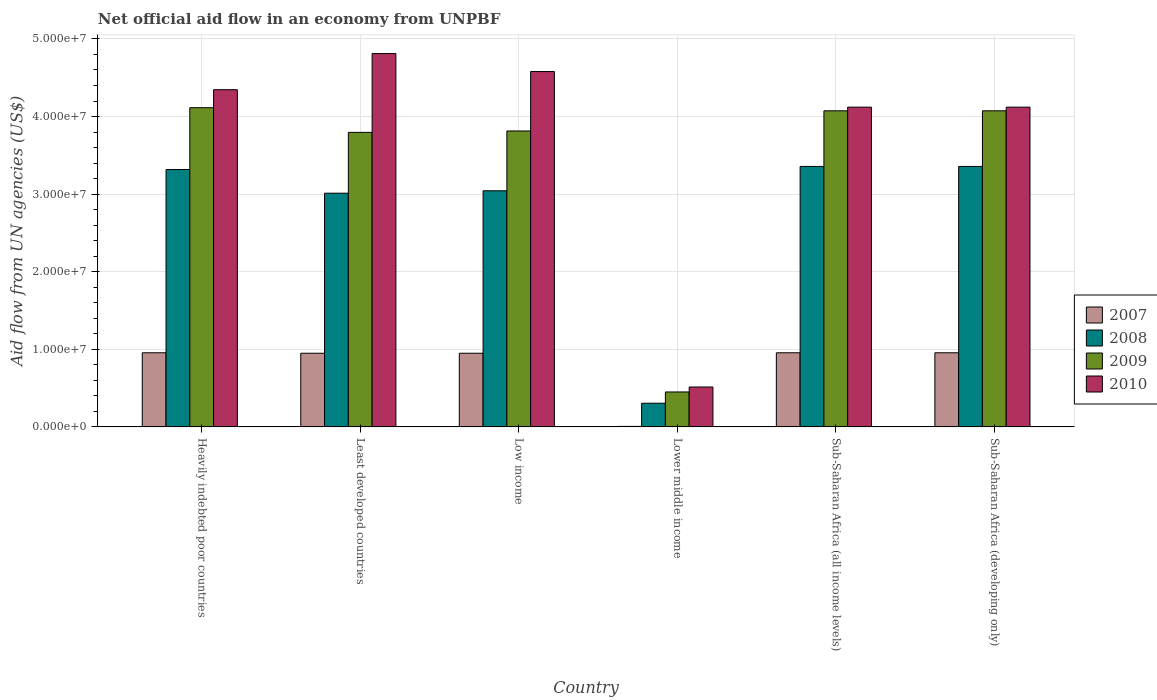How many different coloured bars are there?
Provide a short and direct response. 4. How many groups of bars are there?
Provide a short and direct response. 6. How many bars are there on the 3rd tick from the left?
Make the answer very short. 4. How many bars are there on the 2nd tick from the right?
Offer a terse response. 4. What is the label of the 5th group of bars from the left?
Offer a terse response. Sub-Saharan Africa (all income levels). In how many cases, is the number of bars for a given country not equal to the number of legend labels?
Your response must be concise. 0. What is the net official aid flow in 2007 in Sub-Saharan Africa (all income levels)?
Offer a terse response. 9.55e+06. Across all countries, what is the maximum net official aid flow in 2008?
Offer a terse response. 3.36e+07. Across all countries, what is the minimum net official aid flow in 2008?
Give a very brief answer. 3.05e+06. In which country was the net official aid flow in 2009 maximum?
Provide a short and direct response. Heavily indebted poor countries. In which country was the net official aid flow in 2009 minimum?
Provide a short and direct response. Lower middle income. What is the total net official aid flow in 2010 in the graph?
Ensure brevity in your answer.  2.25e+08. What is the difference between the net official aid flow in 2008 in Heavily indebted poor countries and that in Sub-Saharan Africa (developing only)?
Provide a succinct answer. -4.00e+05. What is the difference between the net official aid flow in 2010 in Sub-Saharan Africa (developing only) and the net official aid flow in 2007 in Sub-Saharan Africa (all income levels)?
Offer a very short reply. 3.17e+07. What is the average net official aid flow in 2010 per country?
Ensure brevity in your answer.  3.75e+07. What is the difference between the net official aid flow of/in 2009 and net official aid flow of/in 2010 in Low income?
Offer a very short reply. -7.66e+06. What is the ratio of the net official aid flow in 2007 in Sub-Saharan Africa (all income levels) to that in Sub-Saharan Africa (developing only)?
Keep it short and to the point. 1. Is the net official aid flow in 2008 in Least developed countries less than that in Low income?
Give a very brief answer. Yes. What is the difference between the highest and the second highest net official aid flow in 2009?
Offer a terse response. 4.00e+05. What is the difference between the highest and the lowest net official aid flow in 2010?
Give a very brief answer. 4.30e+07. Is the sum of the net official aid flow in 2009 in Heavily indebted poor countries and Lower middle income greater than the maximum net official aid flow in 2007 across all countries?
Your answer should be very brief. Yes. Is it the case that in every country, the sum of the net official aid flow in 2009 and net official aid flow in 2007 is greater than the sum of net official aid flow in 2010 and net official aid flow in 2008?
Your response must be concise. No. What does the 4th bar from the left in Sub-Saharan Africa (developing only) represents?
Keep it short and to the point. 2010. How many countries are there in the graph?
Provide a succinct answer. 6. Does the graph contain grids?
Keep it short and to the point. Yes. Where does the legend appear in the graph?
Provide a short and direct response. Center right. How many legend labels are there?
Keep it short and to the point. 4. How are the legend labels stacked?
Give a very brief answer. Vertical. What is the title of the graph?
Keep it short and to the point. Net official aid flow in an economy from UNPBF. What is the label or title of the X-axis?
Your answer should be very brief. Country. What is the label or title of the Y-axis?
Your answer should be compact. Aid flow from UN agencies (US$). What is the Aid flow from UN agencies (US$) of 2007 in Heavily indebted poor countries?
Make the answer very short. 9.55e+06. What is the Aid flow from UN agencies (US$) of 2008 in Heavily indebted poor countries?
Provide a short and direct response. 3.32e+07. What is the Aid flow from UN agencies (US$) of 2009 in Heavily indebted poor countries?
Your response must be concise. 4.11e+07. What is the Aid flow from UN agencies (US$) in 2010 in Heavily indebted poor countries?
Offer a terse response. 4.35e+07. What is the Aid flow from UN agencies (US$) in 2007 in Least developed countries?
Give a very brief answer. 9.49e+06. What is the Aid flow from UN agencies (US$) of 2008 in Least developed countries?
Make the answer very short. 3.01e+07. What is the Aid flow from UN agencies (US$) of 2009 in Least developed countries?
Provide a short and direct response. 3.80e+07. What is the Aid flow from UN agencies (US$) of 2010 in Least developed countries?
Your answer should be very brief. 4.81e+07. What is the Aid flow from UN agencies (US$) of 2007 in Low income?
Offer a very short reply. 9.49e+06. What is the Aid flow from UN agencies (US$) in 2008 in Low income?
Ensure brevity in your answer.  3.04e+07. What is the Aid flow from UN agencies (US$) of 2009 in Low income?
Offer a terse response. 3.81e+07. What is the Aid flow from UN agencies (US$) in 2010 in Low income?
Provide a short and direct response. 4.58e+07. What is the Aid flow from UN agencies (US$) in 2008 in Lower middle income?
Offer a very short reply. 3.05e+06. What is the Aid flow from UN agencies (US$) in 2009 in Lower middle income?
Make the answer very short. 4.50e+06. What is the Aid flow from UN agencies (US$) of 2010 in Lower middle income?
Your response must be concise. 5.14e+06. What is the Aid flow from UN agencies (US$) of 2007 in Sub-Saharan Africa (all income levels)?
Ensure brevity in your answer.  9.55e+06. What is the Aid flow from UN agencies (US$) of 2008 in Sub-Saharan Africa (all income levels)?
Your answer should be compact. 3.36e+07. What is the Aid flow from UN agencies (US$) of 2009 in Sub-Saharan Africa (all income levels)?
Offer a terse response. 4.07e+07. What is the Aid flow from UN agencies (US$) in 2010 in Sub-Saharan Africa (all income levels)?
Your response must be concise. 4.12e+07. What is the Aid flow from UN agencies (US$) in 2007 in Sub-Saharan Africa (developing only)?
Your answer should be compact. 9.55e+06. What is the Aid flow from UN agencies (US$) in 2008 in Sub-Saharan Africa (developing only)?
Provide a short and direct response. 3.36e+07. What is the Aid flow from UN agencies (US$) in 2009 in Sub-Saharan Africa (developing only)?
Your answer should be very brief. 4.07e+07. What is the Aid flow from UN agencies (US$) in 2010 in Sub-Saharan Africa (developing only)?
Provide a succinct answer. 4.12e+07. Across all countries, what is the maximum Aid flow from UN agencies (US$) of 2007?
Make the answer very short. 9.55e+06. Across all countries, what is the maximum Aid flow from UN agencies (US$) of 2008?
Your response must be concise. 3.36e+07. Across all countries, what is the maximum Aid flow from UN agencies (US$) in 2009?
Your answer should be very brief. 4.11e+07. Across all countries, what is the maximum Aid flow from UN agencies (US$) in 2010?
Keep it short and to the point. 4.81e+07. Across all countries, what is the minimum Aid flow from UN agencies (US$) in 2007?
Your answer should be compact. 6.00e+04. Across all countries, what is the minimum Aid flow from UN agencies (US$) of 2008?
Make the answer very short. 3.05e+06. Across all countries, what is the minimum Aid flow from UN agencies (US$) of 2009?
Your answer should be very brief. 4.50e+06. Across all countries, what is the minimum Aid flow from UN agencies (US$) in 2010?
Give a very brief answer. 5.14e+06. What is the total Aid flow from UN agencies (US$) in 2007 in the graph?
Your response must be concise. 4.77e+07. What is the total Aid flow from UN agencies (US$) of 2008 in the graph?
Your response must be concise. 1.64e+08. What is the total Aid flow from UN agencies (US$) of 2009 in the graph?
Offer a very short reply. 2.03e+08. What is the total Aid flow from UN agencies (US$) in 2010 in the graph?
Provide a succinct answer. 2.25e+08. What is the difference between the Aid flow from UN agencies (US$) of 2007 in Heavily indebted poor countries and that in Least developed countries?
Keep it short and to the point. 6.00e+04. What is the difference between the Aid flow from UN agencies (US$) in 2008 in Heavily indebted poor countries and that in Least developed countries?
Your answer should be compact. 3.05e+06. What is the difference between the Aid flow from UN agencies (US$) of 2009 in Heavily indebted poor countries and that in Least developed countries?
Offer a terse response. 3.18e+06. What is the difference between the Aid flow from UN agencies (US$) of 2010 in Heavily indebted poor countries and that in Least developed countries?
Provide a short and direct response. -4.66e+06. What is the difference between the Aid flow from UN agencies (US$) of 2007 in Heavily indebted poor countries and that in Low income?
Offer a very short reply. 6.00e+04. What is the difference between the Aid flow from UN agencies (US$) of 2008 in Heavily indebted poor countries and that in Low income?
Ensure brevity in your answer.  2.74e+06. What is the difference between the Aid flow from UN agencies (US$) in 2010 in Heavily indebted poor countries and that in Low income?
Offer a very short reply. -2.34e+06. What is the difference between the Aid flow from UN agencies (US$) of 2007 in Heavily indebted poor countries and that in Lower middle income?
Your response must be concise. 9.49e+06. What is the difference between the Aid flow from UN agencies (US$) in 2008 in Heavily indebted poor countries and that in Lower middle income?
Your answer should be compact. 3.01e+07. What is the difference between the Aid flow from UN agencies (US$) in 2009 in Heavily indebted poor countries and that in Lower middle income?
Offer a terse response. 3.66e+07. What is the difference between the Aid flow from UN agencies (US$) of 2010 in Heavily indebted poor countries and that in Lower middle income?
Provide a short and direct response. 3.83e+07. What is the difference between the Aid flow from UN agencies (US$) of 2008 in Heavily indebted poor countries and that in Sub-Saharan Africa (all income levels)?
Your response must be concise. -4.00e+05. What is the difference between the Aid flow from UN agencies (US$) in 2009 in Heavily indebted poor countries and that in Sub-Saharan Africa (all income levels)?
Provide a succinct answer. 4.00e+05. What is the difference between the Aid flow from UN agencies (US$) in 2010 in Heavily indebted poor countries and that in Sub-Saharan Africa (all income levels)?
Provide a short and direct response. 2.25e+06. What is the difference between the Aid flow from UN agencies (US$) of 2007 in Heavily indebted poor countries and that in Sub-Saharan Africa (developing only)?
Your answer should be compact. 0. What is the difference between the Aid flow from UN agencies (US$) of 2008 in Heavily indebted poor countries and that in Sub-Saharan Africa (developing only)?
Make the answer very short. -4.00e+05. What is the difference between the Aid flow from UN agencies (US$) in 2009 in Heavily indebted poor countries and that in Sub-Saharan Africa (developing only)?
Give a very brief answer. 4.00e+05. What is the difference between the Aid flow from UN agencies (US$) in 2010 in Heavily indebted poor countries and that in Sub-Saharan Africa (developing only)?
Make the answer very short. 2.25e+06. What is the difference between the Aid flow from UN agencies (US$) of 2007 in Least developed countries and that in Low income?
Provide a short and direct response. 0. What is the difference between the Aid flow from UN agencies (US$) of 2008 in Least developed countries and that in Low income?
Your answer should be compact. -3.10e+05. What is the difference between the Aid flow from UN agencies (US$) of 2010 in Least developed countries and that in Low income?
Provide a short and direct response. 2.32e+06. What is the difference between the Aid flow from UN agencies (US$) of 2007 in Least developed countries and that in Lower middle income?
Provide a succinct answer. 9.43e+06. What is the difference between the Aid flow from UN agencies (US$) in 2008 in Least developed countries and that in Lower middle income?
Offer a terse response. 2.71e+07. What is the difference between the Aid flow from UN agencies (US$) in 2009 in Least developed countries and that in Lower middle income?
Your answer should be very brief. 3.35e+07. What is the difference between the Aid flow from UN agencies (US$) in 2010 in Least developed countries and that in Lower middle income?
Make the answer very short. 4.30e+07. What is the difference between the Aid flow from UN agencies (US$) of 2008 in Least developed countries and that in Sub-Saharan Africa (all income levels)?
Ensure brevity in your answer.  -3.45e+06. What is the difference between the Aid flow from UN agencies (US$) in 2009 in Least developed countries and that in Sub-Saharan Africa (all income levels)?
Provide a short and direct response. -2.78e+06. What is the difference between the Aid flow from UN agencies (US$) of 2010 in Least developed countries and that in Sub-Saharan Africa (all income levels)?
Your answer should be compact. 6.91e+06. What is the difference between the Aid flow from UN agencies (US$) of 2008 in Least developed countries and that in Sub-Saharan Africa (developing only)?
Offer a terse response. -3.45e+06. What is the difference between the Aid flow from UN agencies (US$) in 2009 in Least developed countries and that in Sub-Saharan Africa (developing only)?
Make the answer very short. -2.78e+06. What is the difference between the Aid flow from UN agencies (US$) of 2010 in Least developed countries and that in Sub-Saharan Africa (developing only)?
Keep it short and to the point. 6.91e+06. What is the difference between the Aid flow from UN agencies (US$) of 2007 in Low income and that in Lower middle income?
Your response must be concise. 9.43e+06. What is the difference between the Aid flow from UN agencies (US$) in 2008 in Low income and that in Lower middle income?
Keep it short and to the point. 2.74e+07. What is the difference between the Aid flow from UN agencies (US$) in 2009 in Low income and that in Lower middle income?
Offer a terse response. 3.36e+07. What is the difference between the Aid flow from UN agencies (US$) of 2010 in Low income and that in Lower middle income?
Your answer should be compact. 4.07e+07. What is the difference between the Aid flow from UN agencies (US$) in 2008 in Low income and that in Sub-Saharan Africa (all income levels)?
Your answer should be very brief. -3.14e+06. What is the difference between the Aid flow from UN agencies (US$) in 2009 in Low income and that in Sub-Saharan Africa (all income levels)?
Offer a terse response. -2.60e+06. What is the difference between the Aid flow from UN agencies (US$) of 2010 in Low income and that in Sub-Saharan Africa (all income levels)?
Provide a short and direct response. 4.59e+06. What is the difference between the Aid flow from UN agencies (US$) of 2008 in Low income and that in Sub-Saharan Africa (developing only)?
Make the answer very short. -3.14e+06. What is the difference between the Aid flow from UN agencies (US$) in 2009 in Low income and that in Sub-Saharan Africa (developing only)?
Keep it short and to the point. -2.60e+06. What is the difference between the Aid flow from UN agencies (US$) of 2010 in Low income and that in Sub-Saharan Africa (developing only)?
Offer a terse response. 4.59e+06. What is the difference between the Aid flow from UN agencies (US$) of 2007 in Lower middle income and that in Sub-Saharan Africa (all income levels)?
Give a very brief answer. -9.49e+06. What is the difference between the Aid flow from UN agencies (US$) of 2008 in Lower middle income and that in Sub-Saharan Africa (all income levels)?
Offer a terse response. -3.05e+07. What is the difference between the Aid flow from UN agencies (US$) of 2009 in Lower middle income and that in Sub-Saharan Africa (all income levels)?
Your answer should be compact. -3.62e+07. What is the difference between the Aid flow from UN agencies (US$) of 2010 in Lower middle income and that in Sub-Saharan Africa (all income levels)?
Your answer should be very brief. -3.61e+07. What is the difference between the Aid flow from UN agencies (US$) of 2007 in Lower middle income and that in Sub-Saharan Africa (developing only)?
Provide a succinct answer. -9.49e+06. What is the difference between the Aid flow from UN agencies (US$) in 2008 in Lower middle income and that in Sub-Saharan Africa (developing only)?
Ensure brevity in your answer.  -3.05e+07. What is the difference between the Aid flow from UN agencies (US$) of 2009 in Lower middle income and that in Sub-Saharan Africa (developing only)?
Give a very brief answer. -3.62e+07. What is the difference between the Aid flow from UN agencies (US$) in 2010 in Lower middle income and that in Sub-Saharan Africa (developing only)?
Offer a terse response. -3.61e+07. What is the difference between the Aid flow from UN agencies (US$) of 2008 in Sub-Saharan Africa (all income levels) and that in Sub-Saharan Africa (developing only)?
Offer a very short reply. 0. What is the difference between the Aid flow from UN agencies (US$) in 2007 in Heavily indebted poor countries and the Aid flow from UN agencies (US$) in 2008 in Least developed countries?
Give a very brief answer. -2.06e+07. What is the difference between the Aid flow from UN agencies (US$) in 2007 in Heavily indebted poor countries and the Aid flow from UN agencies (US$) in 2009 in Least developed countries?
Your response must be concise. -2.84e+07. What is the difference between the Aid flow from UN agencies (US$) in 2007 in Heavily indebted poor countries and the Aid flow from UN agencies (US$) in 2010 in Least developed countries?
Your response must be concise. -3.86e+07. What is the difference between the Aid flow from UN agencies (US$) in 2008 in Heavily indebted poor countries and the Aid flow from UN agencies (US$) in 2009 in Least developed countries?
Your answer should be compact. -4.79e+06. What is the difference between the Aid flow from UN agencies (US$) of 2008 in Heavily indebted poor countries and the Aid flow from UN agencies (US$) of 2010 in Least developed countries?
Ensure brevity in your answer.  -1.50e+07. What is the difference between the Aid flow from UN agencies (US$) of 2009 in Heavily indebted poor countries and the Aid flow from UN agencies (US$) of 2010 in Least developed countries?
Your response must be concise. -6.98e+06. What is the difference between the Aid flow from UN agencies (US$) in 2007 in Heavily indebted poor countries and the Aid flow from UN agencies (US$) in 2008 in Low income?
Give a very brief answer. -2.09e+07. What is the difference between the Aid flow from UN agencies (US$) in 2007 in Heavily indebted poor countries and the Aid flow from UN agencies (US$) in 2009 in Low income?
Provide a succinct answer. -2.86e+07. What is the difference between the Aid flow from UN agencies (US$) in 2007 in Heavily indebted poor countries and the Aid flow from UN agencies (US$) in 2010 in Low income?
Ensure brevity in your answer.  -3.62e+07. What is the difference between the Aid flow from UN agencies (US$) of 2008 in Heavily indebted poor countries and the Aid flow from UN agencies (US$) of 2009 in Low income?
Give a very brief answer. -4.97e+06. What is the difference between the Aid flow from UN agencies (US$) of 2008 in Heavily indebted poor countries and the Aid flow from UN agencies (US$) of 2010 in Low income?
Make the answer very short. -1.26e+07. What is the difference between the Aid flow from UN agencies (US$) of 2009 in Heavily indebted poor countries and the Aid flow from UN agencies (US$) of 2010 in Low income?
Your answer should be very brief. -4.66e+06. What is the difference between the Aid flow from UN agencies (US$) in 2007 in Heavily indebted poor countries and the Aid flow from UN agencies (US$) in 2008 in Lower middle income?
Provide a succinct answer. 6.50e+06. What is the difference between the Aid flow from UN agencies (US$) of 2007 in Heavily indebted poor countries and the Aid flow from UN agencies (US$) of 2009 in Lower middle income?
Provide a succinct answer. 5.05e+06. What is the difference between the Aid flow from UN agencies (US$) in 2007 in Heavily indebted poor countries and the Aid flow from UN agencies (US$) in 2010 in Lower middle income?
Make the answer very short. 4.41e+06. What is the difference between the Aid flow from UN agencies (US$) of 2008 in Heavily indebted poor countries and the Aid flow from UN agencies (US$) of 2009 in Lower middle income?
Your answer should be very brief. 2.87e+07. What is the difference between the Aid flow from UN agencies (US$) in 2008 in Heavily indebted poor countries and the Aid flow from UN agencies (US$) in 2010 in Lower middle income?
Your response must be concise. 2.80e+07. What is the difference between the Aid flow from UN agencies (US$) of 2009 in Heavily indebted poor countries and the Aid flow from UN agencies (US$) of 2010 in Lower middle income?
Your answer should be compact. 3.60e+07. What is the difference between the Aid flow from UN agencies (US$) in 2007 in Heavily indebted poor countries and the Aid flow from UN agencies (US$) in 2008 in Sub-Saharan Africa (all income levels)?
Provide a short and direct response. -2.40e+07. What is the difference between the Aid flow from UN agencies (US$) of 2007 in Heavily indebted poor countries and the Aid flow from UN agencies (US$) of 2009 in Sub-Saharan Africa (all income levels)?
Ensure brevity in your answer.  -3.12e+07. What is the difference between the Aid flow from UN agencies (US$) in 2007 in Heavily indebted poor countries and the Aid flow from UN agencies (US$) in 2010 in Sub-Saharan Africa (all income levels)?
Your answer should be compact. -3.17e+07. What is the difference between the Aid flow from UN agencies (US$) in 2008 in Heavily indebted poor countries and the Aid flow from UN agencies (US$) in 2009 in Sub-Saharan Africa (all income levels)?
Ensure brevity in your answer.  -7.57e+06. What is the difference between the Aid flow from UN agencies (US$) of 2008 in Heavily indebted poor countries and the Aid flow from UN agencies (US$) of 2010 in Sub-Saharan Africa (all income levels)?
Offer a very short reply. -8.04e+06. What is the difference between the Aid flow from UN agencies (US$) in 2009 in Heavily indebted poor countries and the Aid flow from UN agencies (US$) in 2010 in Sub-Saharan Africa (all income levels)?
Give a very brief answer. -7.00e+04. What is the difference between the Aid flow from UN agencies (US$) of 2007 in Heavily indebted poor countries and the Aid flow from UN agencies (US$) of 2008 in Sub-Saharan Africa (developing only)?
Your response must be concise. -2.40e+07. What is the difference between the Aid flow from UN agencies (US$) of 2007 in Heavily indebted poor countries and the Aid flow from UN agencies (US$) of 2009 in Sub-Saharan Africa (developing only)?
Your answer should be very brief. -3.12e+07. What is the difference between the Aid flow from UN agencies (US$) of 2007 in Heavily indebted poor countries and the Aid flow from UN agencies (US$) of 2010 in Sub-Saharan Africa (developing only)?
Make the answer very short. -3.17e+07. What is the difference between the Aid flow from UN agencies (US$) in 2008 in Heavily indebted poor countries and the Aid flow from UN agencies (US$) in 2009 in Sub-Saharan Africa (developing only)?
Provide a short and direct response. -7.57e+06. What is the difference between the Aid flow from UN agencies (US$) in 2008 in Heavily indebted poor countries and the Aid flow from UN agencies (US$) in 2010 in Sub-Saharan Africa (developing only)?
Offer a very short reply. -8.04e+06. What is the difference between the Aid flow from UN agencies (US$) in 2009 in Heavily indebted poor countries and the Aid flow from UN agencies (US$) in 2010 in Sub-Saharan Africa (developing only)?
Your answer should be compact. -7.00e+04. What is the difference between the Aid flow from UN agencies (US$) in 2007 in Least developed countries and the Aid flow from UN agencies (US$) in 2008 in Low income?
Offer a terse response. -2.09e+07. What is the difference between the Aid flow from UN agencies (US$) in 2007 in Least developed countries and the Aid flow from UN agencies (US$) in 2009 in Low income?
Ensure brevity in your answer.  -2.86e+07. What is the difference between the Aid flow from UN agencies (US$) of 2007 in Least developed countries and the Aid flow from UN agencies (US$) of 2010 in Low income?
Make the answer very short. -3.63e+07. What is the difference between the Aid flow from UN agencies (US$) of 2008 in Least developed countries and the Aid flow from UN agencies (US$) of 2009 in Low income?
Keep it short and to the point. -8.02e+06. What is the difference between the Aid flow from UN agencies (US$) of 2008 in Least developed countries and the Aid flow from UN agencies (US$) of 2010 in Low income?
Provide a succinct answer. -1.57e+07. What is the difference between the Aid flow from UN agencies (US$) of 2009 in Least developed countries and the Aid flow from UN agencies (US$) of 2010 in Low income?
Your response must be concise. -7.84e+06. What is the difference between the Aid flow from UN agencies (US$) in 2007 in Least developed countries and the Aid flow from UN agencies (US$) in 2008 in Lower middle income?
Provide a short and direct response. 6.44e+06. What is the difference between the Aid flow from UN agencies (US$) of 2007 in Least developed countries and the Aid flow from UN agencies (US$) of 2009 in Lower middle income?
Your answer should be compact. 4.99e+06. What is the difference between the Aid flow from UN agencies (US$) in 2007 in Least developed countries and the Aid flow from UN agencies (US$) in 2010 in Lower middle income?
Provide a succinct answer. 4.35e+06. What is the difference between the Aid flow from UN agencies (US$) of 2008 in Least developed countries and the Aid flow from UN agencies (US$) of 2009 in Lower middle income?
Provide a short and direct response. 2.56e+07. What is the difference between the Aid flow from UN agencies (US$) in 2008 in Least developed countries and the Aid flow from UN agencies (US$) in 2010 in Lower middle income?
Make the answer very short. 2.50e+07. What is the difference between the Aid flow from UN agencies (US$) of 2009 in Least developed countries and the Aid flow from UN agencies (US$) of 2010 in Lower middle income?
Offer a very short reply. 3.28e+07. What is the difference between the Aid flow from UN agencies (US$) of 2007 in Least developed countries and the Aid flow from UN agencies (US$) of 2008 in Sub-Saharan Africa (all income levels)?
Ensure brevity in your answer.  -2.41e+07. What is the difference between the Aid flow from UN agencies (US$) of 2007 in Least developed countries and the Aid flow from UN agencies (US$) of 2009 in Sub-Saharan Africa (all income levels)?
Keep it short and to the point. -3.12e+07. What is the difference between the Aid flow from UN agencies (US$) of 2007 in Least developed countries and the Aid flow from UN agencies (US$) of 2010 in Sub-Saharan Africa (all income levels)?
Your answer should be very brief. -3.17e+07. What is the difference between the Aid flow from UN agencies (US$) of 2008 in Least developed countries and the Aid flow from UN agencies (US$) of 2009 in Sub-Saharan Africa (all income levels)?
Offer a terse response. -1.06e+07. What is the difference between the Aid flow from UN agencies (US$) in 2008 in Least developed countries and the Aid flow from UN agencies (US$) in 2010 in Sub-Saharan Africa (all income levels)?
Offer a terse response. -1.11e+07. What is the difference between the Aid flow from UN agencies (US$) in 2009 in Least developed countries and the Aid flow from UN agencies (US$) in 2010 in Sub-Saharan Africa (all income levels)?
Your answer should be very brief. -3.25e+06. What is the difference between the Aid flow from UN agencies (US$) of 2007 in Least developed countries and the Aid flow from UN agencies (US$) of 2008 in Sub-Saharan Africa (developing only)?
Offer a terse response. -2.41e+07. What is the difference between the Aid flow from UN agencies (US$) in 2007 in Least developed countries and the Aid flow from UN agencies (US$) in 2009 in Sub-Saharan Africa (developing only)?
Your answer should be very brief. -3.12e+07. What is the difference between the Aid flow from UN agencies (US$) in 2007 in Least developed countries and the Aid flow from UN agencies (US$) in 2010 in Sub-Saharan Africa (developing only)?
Keep it short and to the point. -3.17e+07. What is the difference between the Aid flow from UN agencies (US$) of 2008 in Least developed countries and the Aid flow from UN agencies (US$) of 2009 in Sub-Saharan Africa (developing only)?
Your response must be concise. -1.06e+07. What is the difference between the Aid flow from UN agencies (US$) of 2008 in Least developed countries and the Aid flow from UN agencies (US$) of 2010 in Sub-Saharan Africa (developing only)?
Make the answer very short. -1.11e+07. What is the difference between the Aid flow from UN agencies (US$) in 2009 in Least developed countries and the Aid flow from UN agencies (US$) in 2010 in Sub-Saharan Africa (developing only)?
Provide a succinct answer. -3.25e+06. What is the difference between the Aid flow from UN agencies (US$) in 2007 in Low income and the Aid flow from UN agencies (US$) in 2008 in Lower middle income?
Keep it short and to the point. 6.44e+06. What is the difference between the Aid flow from UN agencies (US$) in 2007 in Low income and the Aid flow from UN agencies (US$) in 2009 in Lower middle income?
Offer a very short reply. 4.99e+06. What is the difference between the Aid flow from UN agencies (US$) in 2007 in Low income and the Aid flow from UN agencies (US$) in 2010 in Lower middle income?
Provide a succinct answer. 4.35e+06. What is the difference between the Aid flow from UN agencies (US$) of 2008 in Low income and the Aid flow from UN agencies (US$) of 2009 in Lower middle income?
Make the answer very short. 2.59e+07. What is the difference between the Aid flow from UN agencies (US$) in 2008 in Low income and the Aid flow from UN agencies (US$) in 2010 in Lower middle income?
Provide a short and direct response. 2.53e+07. What is the difference between the Aid flow from UN agencies (US$) of 2009 in Low income and the Aid flow from UN agencies (US$) of 2010 in Lower middle income?
Your answer should be very brief. 3.30e+07. What is the difference between the Aid flow from UN agencies (US$) of 2007 in Low income and the Aid flow from UN agencies (US$) of 2008 in Sub-Saharan Africa (all income levels)?
Provide a succinct answer. -2.41e+07. What is the difference between the Aid flow from UN agencies (US$) in 2007 in Low income and the Aid flow from UN agencies (US$) in 2009 in Sub-Saharan Africa (all income levels)?
Make the answer very short. -3.12e+07. What is the difference between the Aid flow from UN agencies (US$) in 2007 in Low income and the Aid flow from UN agencies (US$) in 2010 in Sub-Saharan Africa (all income levels)?
Give a very brief answer. -3.17e+07. What is the difference between the Aid flow from UN agencies (US$) of 2008 in Low income and the Aid flow from UN agencies (US$) of 2009 in Sub-Saharan Africa (all income levels)?
Your answer should be compact. -1.03e+07. What is the difference between the Aid flow from UN agencies (US$) of 2008 in Low income and the Aid flow from UN agencies (US$) of 2010 in Sub-Saharan Africa (all income levels)?
Your answer should be compact. -1.08e+07. What is the difference between the Aid flow from UN agencies (US$) of 2009 in Low income and the Aid flow from UN agencies (US$) of 2010 in Sub-Saharan Africa (all income levels)?
Your answer should be compact. -3.07e+06. What is the difference between the Aid flow from UN agencies (US$) in 2007 in Low income and the Aid flow from UN agencies (US$) in 2008 in Sub-Saharan Africa (developing only)?
Your answer should be compact. -2.41e+07. What is the difference between the Aid flow from UN agencies (US$) in 2007 in Low income and the Aid flow from UN agencies (US$) in 2009 in Sub-Saharan Africa (developing only)?
Your response must be concise. -3.12e+07. What is the difference between the Aid flow from UN agencies (US$) in 2007 in Low income and the Aid flow from UN agencies (US$) in 2010 in Sub-Saharan Africa (developing only)?
Give a very brief answer. -3.17e+07. What is the difference between the Aid flow from UN agencies (US$) in 2008 in Low income and the Aid flow from UN agencies (US$) in 2009 in Sub-Saharan Africa (developing only)?
Offer a terse response. -1.03e+07. What is the difference between the Aid flow from UN agencies (US$) of 2008 in Low income and the Aid flow from UN agencies (US$) of 2010 in Sub-Saharan Africa (developing only)?
Provide a succinct answer. -1.08e+07. What is the difference between the Aid flow from UN agencies (US$) of 2009 in Low income and the Aid flow from UN agencies (US$) of 2010 in Sub-Saharan Africa (developing only)?
Make the answer very short. -3.07e+06. What is the difference between the Aid flow from UN agencies (US$) in 2007 in Lower middle income and the Aid flow from UN agencies (US$) in 2008 in Sub-Saharan Africa (all income levels)?
Provide a succinct answer. -3.35e+07. What is the difference between the Aid flow from UN agencies (US$) in 2007 in Lower middle income and the Aid flow from UN agencies (US$) in 2009 in Sub-Saharan Africa (all income levels)?
Provide a succinct answer. -4.07e+07. What is the difference between the Aid flow from UN agencies (US$) in 2007 in Lower middle income and the Aid flow from UN agencies (US$) in 2010 in Sub-Saharan Africa (all income levels)?
Make the answer very short. -4.12e+07. What is the difference between the Aid flow from UN agencies (US$) of 2008 in Lower middle income and the Aid flow from UN agencies (US$) of 2009 in Sub-Saharan Africa (all income levels)?
Keep it short and to the point. -3.77e+07. What is the difference between the Aid flow from UN agencies (US$) in 2008 in Lower middle income and the Aid flow from UN agencies (US$) in 2010 in Sub-Saharan Africa (all income levels)?
Give a very brief answer. -3.82e+07. What is the difference between the Aid flow from UN agencies (US$) in 2009 in Lower middle income and the Aid flow from UN agencies (US$) in 2010 in Sub-Saharan Africa (all income levels)?
Keep it short and to the point. -3.67e+07. What is the difference between the Aid flow from UN agencies (US$) in 2007 in Lower middle income and the Aid flow from UN agencies (US$) in 2008 in Sub-Saharan Africa (developing only)?
Provide a succinct answer. -3.35e+07. What is the difference between the Aid flow from UN agencies (US$) of 2007 in Lower middle income and the Aid flow from UN agencies (US$) of 2009 in Sub-Saharan Africa (developing only)?
Make the answer very short. -4.07e+07. What is the difference between the Aid flow from UN agencies (US$) in 2007 in Lower middle income and the Aid flow from UN agencies (US$) in 2010 in Sub-Saharan Africa (developing only)?
Your response must be concise. -4.12e+07. What is the difference between the Aid flow from UN agencies (US$) of 2008 in Lower middle income and the Aid flow from UN agencies (US$) of 2009 in Sub-Saharan Africa (developing only)?
Provide a short and direct response. -3.77e+07. What is the difference between the Aid flow from UN agencies (US$) in 2008 in Lower middle income and the Aid flow from UN agencies (US$) in 2010 in Sub-Saharan Africa (developing only)?
Provide a short and direct response. -3.82e+07. What is the difference between the Aid flow from UN agencies (US$) of 2009 in Lower middle income and the Aid flow from UN agencies (US$) of 2010 in Sub-Saharan Africa (developing only)?
Your answer should be very brief. -3.67e+07. What is the difference between the Aid flow from UN agencies (US$) of 2007 in Sub-Saharan Africa (all income levels) and the Aid flow from UN agencies (US$) of 2008 in Sub-Saharan Africa (developing only)?
Provide a succinct answer. -2.40e+07. What is the difference between the Aid flow from UN agencies (US$) in 2007 in Sub-Saharan Africa (all income levels) and the Aid flow from UN agencies (US$) in 2009 in Sub-Saharan Africa (developing only)?
Ensure brevity in your answer.  -3.12e+07. What is the difference between the Aid flow from UN agencies (US$) of 2007 in Sub-Saharan Africa (all income levels) and the Aid flow from UN agencies (US$) of 2010 in Sub-Saharan Africa (developing only)?
Offer a terse response. -3.17e+07. What is the difference between the Aid flow from UN agencies (US$) in 2008 in Sub-Saharan Africa (all income levels) and the Aid flow from UN agencies (US$) in 2009 in Sub-Saharan Africa (developing only)?
Provide a succinct answer. -7.17e+06. What is the difference between the Aid flow from UN agencies (US$) in 2008 in Sub-Saharan Africa (all income levels) and the Aid flow from UN agencies (US$) in 2010 in Sub-Saharan Africa (developing only)?
Your answer should be very brief. -7.64e+06. What is the difference between the Aid flow from UN agencies (US$) of 2009 in Sub-Saharan Africa (all income levels) and the Aid flow from UN agencies (US$) of 2010 in Sub-Saharan Africa (developing only)?
Your answer should be compact. -4.70e+05. What is the average Aid flow from UN agencies (US$) of 2007 per country?
Offer a terse response. 7.95e+06. What is the average Aid flow from UN agencies (US$) of 2008 per country?
Provide a short and direct response. 2.73e+07. What is the average Aid flow from UN agencies (US$) in 2009 per country?
Give a very brief answer. 3.39e+07. What is the average Aid flow from UN agencies (US$) in 2010 per country?
Give a very brief answer. 3.75e+07. What is the difference between the Aid flow from UN agencies (US$) of 2007 and Aid flow from UN agencies (US$) of 2008 in Heavily indebted poor countries?
Offer a very short reply. -2.36e+07. What is the difference between the Aid flow from UN agencies (US$) of 2007 and Aid flow from UN agencies (US$) of 2009 in Heavily indebted poor countries?
Give a very brief answer. -3.16e+07. What is the difference between the Aid flow from UN agencies (US$) of 2007 and Aid flow from UN agencies (US$) of 2010 in Heavily indebted poor countries?
Your answer should be very brief. -3.39e+07. What is the difference between the Aid flow from UN agencies (US$) in 2008 and Aid flow from UN agencies (US$) in 2009 in Heavily indebted poor countries?
Offer a terse response. -7.97e+06. What is the difference between the Aid flow from UN agencies (US$) of 2008 and Aid flow from UN agencies (US$) of 2010 in Heavily indebted poor countries?
Offer a terse response. -1.03e+07. What is the difference between the Aid flow from UN agencies (US$) of 2009 and Aid flow from UN agencies (US$) of 2010 in Heavily indebted poor countries?
Give a very brief answer. -2.32e+06. What is the difference between the Aid flow from UN agencies (US$) in 2007 and Aid flow from UN agencies (US$) in 2008 in Least developed countries?
Provide a succinct answer. -2.06e+07. What is the difference between the Aid flow from UN agencies (US$) in 2007 and Aid flow from UN agencies (US$) in 2009 in Least developed countries?
Make the answer very short. -2.85e+07. What is the difference between the Aid flow from UN agencies (US$) in 2007 and Aid flow from UN agencies (US$) in 2010 in Least developed countries?
Provide a succinct answer. -3.86e+07. What is the difference between the Aid flow from UN agencies (US$) in 2008 and Aid flow from UN agencies (US$) in 2009 in Least developed countries?
Provide a short and direct response. -7.84e+06. What is the difference between the Aid flow from UN agencies (US$) in 2008 and Aid flow from UN agencies (US$) in 2010 in Least developed countries?
Your answer should be compact. -1.80e+07. What is the difference between the Aid flow from UN agencies (US$) in 2009 and Aid flow from UN agencies (US$) in 2010 in Least developed countries?
Your response must be concise. -1.02e+07. What is the difference between the Aid flow from UN agencies (US$) of 2007 and Aid flow from UN agencies (US$) of 2008 in Low income?
Your answer should be compact. -2.09e+07. What is the difference between the Aid flow from UN agencies (US$) of 2007 and Aid flow from UN agencies (US$) of 2009 in Low income?
Your answer should be very brief. -2.86e+07. What is the difference between the Aid flow from UN agencies (US$) in 2007 and Aid flow from UN agencies (US$) in 2010 in Low income?
Keep it short and to the point. -3.63e+07. What is the difference between the Aid flow from UN agencies (US$) of 2008 and Aid flow from UN agencies (US$) of 2009 in Low income?
Your answer should be very brief. -7.71e+06. What is the difference between the Aid flow from UN agencies (US$) in 2008 and Aid flow from UN agencies (US$) in 2010 in Low income?
Offer a very short reply. -1.54e+07. What is the difference between the Aid flow from UN agencies (US$) in 2009 and Aid flow from UN agencies (US$) in 2010 in Low income?
Your answer should be compact. -7.66e+06. What is the difference between the Aid flow from UN agencies (US$) of 2007 and Aid flow from UN agencies (US$) of 2008 in Lower middle income?
Provide a succinct answer. -2.99e+06. What is the difference between the Aid flow from UN agencies (US$) of 2007 and Aid flow from UN agencies (US$) of 2009 in Lower middle income?
Your response must be concise. -4.44e+06. What is the difference between the Aid flow from UN agencies (US$) of 2007 and Aid flow from UN agencies (US$) of 2010 in Lower middle income?
Provide a succinct answer. -5.08e+06. What is the difference between the Aid flow from UN agencies (US$) in 2008 and Aid flow from UN agencies (US$) in 2009 in Lower middle income?
Your answer should be compact. -1.45e+06. What is the difference between the Aid flow from UN agencies (US$) in 2008 and Aid flow from UN agencies (US$) in 2010 in Lower middle income?
Offer a terse response. -2.09e+06. What is the difference between the Aid flow from UN agencies (US$) of 2009 and Aid flow from UN agencies (US$) of 2010 in Lower middle income?
Provide a succinct answer. -6.40e+05. What is the difference between the Aid flow from UN agencies (US$) in 2007 and Aid flow from UN agencies (US$) in 2008 in Sub-Saharan Africa (all income levels)?
Ensure brevity in your answer.  -2.40e+07. What is the difference between the Aid flow from UN agencies (US$) in 2007 and Aid flow from UN agencies (US$) in 2009 in Sub-Saharan Africa (all income levels)?
Provide a succinct answer. -3.12e+07. What is the difference between the Aid flow from UN agencies (US$) of 2007 and Aid flow from UN agencies (US$) of 2010 in Sub-Saharan Africa (all income levels)?
Your answer should be very brief. -3.17e+07. What is the difference between the Aid flow from UN agencies (US$) of 2008 and Aid flow from UN agencies (US$) of 2009 in Sub-Saharan Africa (all income levels)?
Your response must be concise. -7.17e+06. What is the difference between the Aid flow from UN agencies (US$) of 2008 and Aid flow from UN agencies (US$) of 2010 in Sub-Saharan Africa (all income levels)?
Your answer should be compact. -7.64e+06. What is the difference between the Aid flow from UN agencies (US$) in 2009 and Aid flow from UN agencies (US$) in 2010 in Sub-Saharan Africa (all income levels)?
Your answer should be very brief. -4.70e+05. What is the difference between the Aid flow from UN agencies (US$) in 2007 and Aid flow from UN agencies (US$) in 2008 in Sub-Saharan Africa (developing only)?
Provide a succinct answer. -2.40e+07. What is the difference between the Aid flow from UN agencies (US$) of 2007 and Aid flow from UN agencies (US$) of 2009 in Sub-Saharan Africa (developing only)?
Your response must be concise. -3.12e+07. What is the difference between the Aid flow from UN agencies (US$) of 2007 and Aid flow from UN agencies (US$) of 2010 in Sub-Saharan Africa (developing only)?
Your answer should be very brief. -3.17e+07. What is the difference between the Aid flow from UN agencies (US$) of 2008 and Aid flow from UN agencies (US$) of 2009 in Sub-Saharan Africa (developing only)?
Keep it short and to the point. -7.17e+06. What is the difference between the Aid flow from UN agencies (US$) in 2008 and Aid flow from UN agencies (US$) in 2010 in Sub-Saharan Africa (developing only)?
Provide a succinct answer. -7.64e+06. What is the difference between the Aid flow from UN agencies (US$) of 2009 and Aid flow from UN agencies (US$) of 2010 in Sub-Saharan Africa (developing only)?
Your answer should be compact. -4.70e+05. What is the ratio of the Aid flow from UN agencies (US$) in 2007 in Heavily indebted poor countries to that in Least developed countries?
Provide a short and direct response. 1.01. What is the ratio of the Aid flow from UN agencies (US$) of 2008 in Heavily indebted poor countries to that in Least developed countries?
Give a very brief answer. 1.1. What is the ratio of the Aid flow from UN agencies (US$) of 2009 in Heavily indebted poor countries to that in Least developed countries?
Your answer should be very brief. 1.08. What is the ratio of the Aid flow from UN agencies (US$) of 2010 in Heavily indebted poor countries to that in Least developed countries?
Your answer should be compact. 0.9. What is the ratio of the Aid flow from UN agencies (US$) of 2008 in Heavily indebted poor countries to that in Low income?
Give a very brief answer. 1.09. What is the ratio of the Aid flow from UN agencies (US$) in 2009 in Heavily indebted poor countries to that in Low income?
Your answer should be very brief. 1.08. What is the ratio of the Aid flow from UN agencies (US$) of 2010 in Heavily indebted poor countries to that in Low income?
Ensure brevity in your answer.  0.95. What is the ratio of the Aid flow from UN agencies (US$) in 2007 in Heavily indebted poor countries to that in Lower middle income?
Your answer should be compact. 159.17. What is the ratio of the Aid flow from UN agencies (US$) of 2008 in Heavily indebted poor countries to that in Lower middle income?
Provide a short and direct response. 10.88. What is the ratio of the Aid flow from UN agencies (US$) in 2009 in Heavily indebted poor countries to that in Lower middle income?
Offer a very short reply. 9.14. What is the ratio of the Aid flow from UN agencies (US$) of 2010 in Heavily indebted poor countries to that in Lower middle income?
Ensure brevity in your answer.  8.46. What is the ratio of the Aid flow from UN agencies (US$) in 2007 in Heavily indebted poor countries to that in Sub-Saharan Africa (all income levels)?
Provide a short and direct response. 1. What is the ratio of the Aid flow from UN agencies (US$) in 2008 in Heavily indebted poor countries to that in Sub-Saharan Africa (all income levels)?
Make the answer very short. 0.99. What is the ratio of the Aid flow from UN agencies (US$) in 2009 in Heavily indebted poor countries to that in Sub-Saharan Africa (all income levels)?
Give a very brief answer. 1.01. What is the ratio of the Aid flow from UN agencies (US$) of 2010 in Heavily indebted poor countries to that in Sub-Saharan Africa (all income levels)?
Offer a very short reply. 1.05. What is the ratio of the Aid flow from UN agencies (US$) of 2007 in Heavily indebted poor countries to that in Sub-Saharan Africa (developing only)?
Provide a succinct answer. 1. What is the ratio of the Aid flow from UN agencies (US$) in 2009 in Heavily indebted poor countries to that in Sub-Saharan Africa (developing only)?
Give a very brief answer. 1.01. What is the ratio of the Aid flow from UN agencies (US$) of 2010 in Heavily indebted poor countries to that in Sub-Saharan Africa (developing only)?
Provide a succinct answer. 1.05. What is the ratio of the Aid flow from UN agencies (US$) in 2010 in Least developed countries to that in Low income?
Your answer should be compact. 1.05. What is the ratio of the Aid flow from UN agencies (US$) of 2007 in Least developed countries to that in Lower middle income?
Keep it short and to the point. 158.17. What is the ratio of the Aid flow from UN agencies (US$) of 2008 in Least developed countries to that in Lower middle income?
Offer a terse response. 9.88. What is the ratio of the Aid flow from UN agencies (US$) in 2009 in Least developed countries to that in Lower middle income?
Ensure brevity in your answer.  8.44. What is the ratio of the Aid flow from UN agencies (US$) of 2010 in Least developed countries to that in Lower middle income?
Your response must be concise. 9.36. What is the ratio of the Aid flow from UN agencies (US$) of 2007 in Least developed countries to that in Sub-Saharan Africa (all income levels)?
Offer a terse response. 0.99. What is the ratio of the Aid flow from UN agencies (US$) of 2008 in Least developed countries to that in Sub-Saharan Africa (all income levels)?
Ensure brevity in your answer.  0.9. What is the ratio of the Aid flow from UN agencies (US$) of 2009 in Least developed countries to that in Sub-Saharan Africa (all income levels)?
Give a very brief answer. 0.93. What is the ratio of the Aid flow from UN agencies (US$) of 2010 in Least developed countries to that in Sub-Saharan Africa (all income levels)?
Offer a terse response. 1.17. What is the ratio of the Aid flow from UN agencies (US$) of 2008 in Least developed countries to that in Sub-Saharan Africa (developing only)?
Offer a very short reply. 0.9. What is the ratio of the Aid flow from UN agencies (US$) in 2009 in Least developed countries to that in Sub-Saharan Africa (developing only)?
Provide a succinct answer. 0.93. What is the ratio of the Aid flow from UN agencies (US$) in 2010 in Least developed countries to that in Sub-Saharan Africa (developing only)?
Keep it short and to the point. 1.17. What is the ratio of the Aid flow from UN agencies (US$) in 2007 in Low income to that in Lower middle income?
Offer a terse response. 158.17. What is the ratio of the Aid flow from UN agencies (US$) of 2008 in Low income to that in Lower middle income?
Your response must be concise. 9.98. What is the ratio of the Aid flow from UN agencies (US$) of 2009 in Low income to that in Lower middle income?
Offer a very short reply. 8.48. What is the ratio of the Aid flow from UN agencies (US$) of 2010 in Low income to that in Lower middle income?
Give a very brief answer. 8.91. What is the ratio of the Aid flow from UN agencies (US$) of 2008 in Low income to that in Sub-Saharan Africa (all income levels)?
Your answer should be very brief. 0.91. What is the ratio of the Aid flow from UN agencies (US$) of 2009 in Low income to that in Sub-Saharan Africa (all income levels)?
Your response must be concise. 0.94. What is the ratio of the Aid flow from UN agencies (US$) of 2010 in Low income to that in Sub-Saharan Africa (all income levels)?
Offer a terse response. 1.11. What is the ratio of the Aid flow from UN agencies (US$) of 2007 in Low income to that in Sub-Saharan Africa (developing only)?
Provide a succinct answer. 0.99. What is the ratio of the Aid flow from UN agencies (US$) of 2008 in Low income to that in Sub-Saharan Africa (developing only)?
Your response must be concise. 0.91. What is the ratio of the Aid flow from UN agencies (US$) in 2009 in Low income to that in Sub-Saharan Africa (developing only)?
Ensure brevity in your answer.  0.94. What is the ratio of the Aid flow from UN agencies (US$) in 2010 in Low income to that in Sub-Saharan Africa (developing only)?
Provide a succinct answer. 1.11. What is the ratio of the Aid flow from UN agencies (US$) of 2007 in Lower middle income to that in Sub-Saharan Africa (all income levels)?
Ensure brevity in your answer.  0.01. What is the ratio of the Aid flow from UN agencies (US$) of 2008 in Lower middle income to that in Sub-Saharan Africa (all income levels)?
Your response must be concise. 0.09. What is the ratio of the Aid flow from UN agencies (US$) in 2009 in Lower middle income to that in Sub-Saharan Africa (all income levels)?
Keep it short and to the point. 0.11. What is the ratio of the Aid flow from UN agencies (US$) of 2010 in Lower middle income to that in Sub-Saharan Africa (all income levels)?
Your answer should be compact. 0.12. What is the ratio of the Aid flow from UN agencies (US$) in 2007 in Lower middle income to that in Sub-Saharan Africa (developing only)?
Ensure brevity in your answer.  0.01. What is the ratio of the Aid flow from UN agencies (US$) in 2008 in Lower middle income to that in Sub-Saharan Africa (developing only)?
Give a very brief answer. 0.09. What is the ratio of the Aid flow from UN agencies (US$) of 2009 in Lower middle income to that in Sub-Saharan Africa (developing only)?
Give a very brief answer. 0.11. What is the ratio of the Aid flow from UN agencies (US$) of 2010 in Lower middle income to that in Sub-Saharan Africa (developing only)?
Your answer should be very brief. 0.12. What is the ratio of the Aid flow from UN agencies (US$) of 2008 in Sub-Saharan Africa (all income levels) to that in Sub-Saharan Africa (developing only)?
Ensure brevity in your answer.  1. What is the ratio of the Aid flow from UN agencies (US$) of 2009 in Sub-Saharan Africa (all income levels) to that in Sub-Saharan Africa (developing only)?
Give a very brief answer. 1. What is the difference between the highest and the second highest Aid flow from UN agencies (US$) in 2010?
Offer a terse response. 2.32e+06. What is the difference between the highest and the lowest Aid flow from UN agencies (US$) of 2007?
Your answer should be very brief. 9.49e+06. What is the difference between the highest and the lowest Aid flow from UN agencies (US$) in 2008?
Ensure brevity in your answer.  3.05e+07. What is the difference between the highest and the lowest Aid flow from UN agencies (US$) in 2009?
Give a very brief answer. 3.66e+07. What is the difference between the highest and the lowest Aid flow from UN agencies (US$) of 2010?
Your answer should be compact. 4.30e+07. 